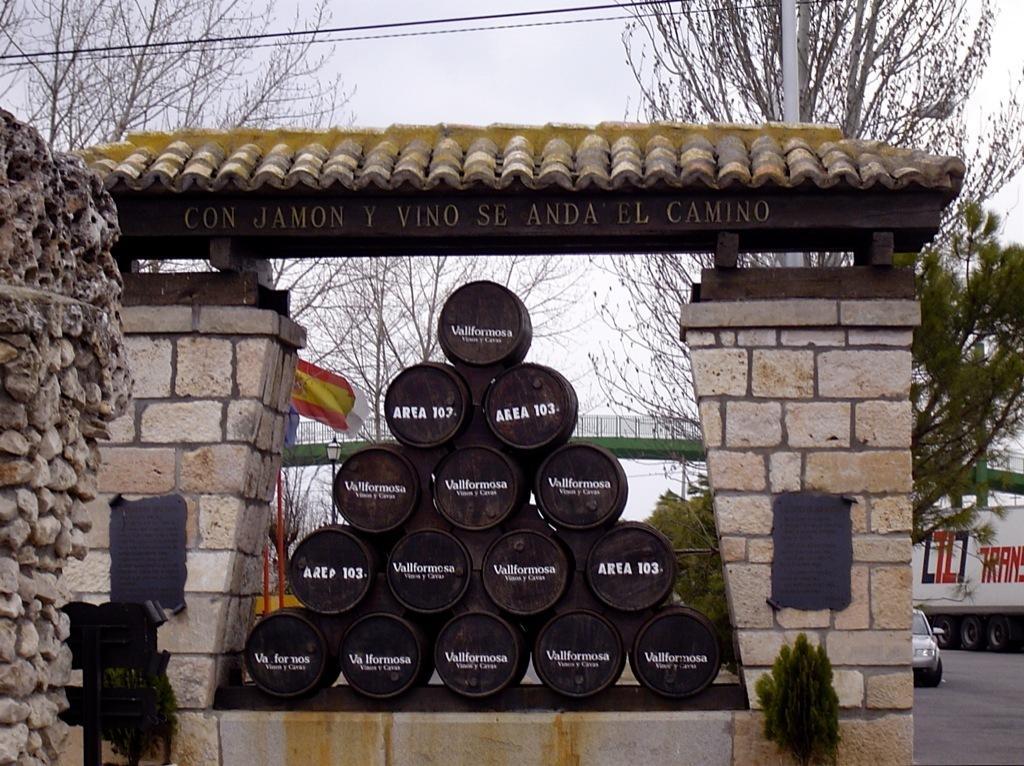In one or two sentences, can you explain what this image depicts? In the center of the image there are barrels arranged in a pyramid shape. To the left side of the image there is wall. To the right side of the image there is a lorry on the road. In the background of the image there are trees. There is a pole. There is a bridge. 